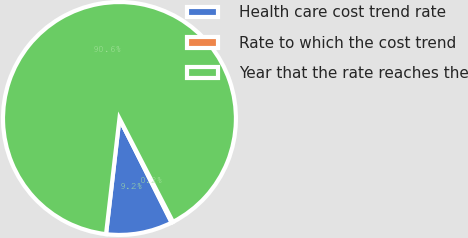Convert chart to OTSL. <chart><loc_0><loc_0><loc_500><loc_500><pie_chart><fcel>Health care cost trend rate<fcel>Rate to which the cost trend<fcel>Year that the rate reaches the<nl><fcel>9.24%<fcel>0.2%<fcel>90.56%<nl></chart> 